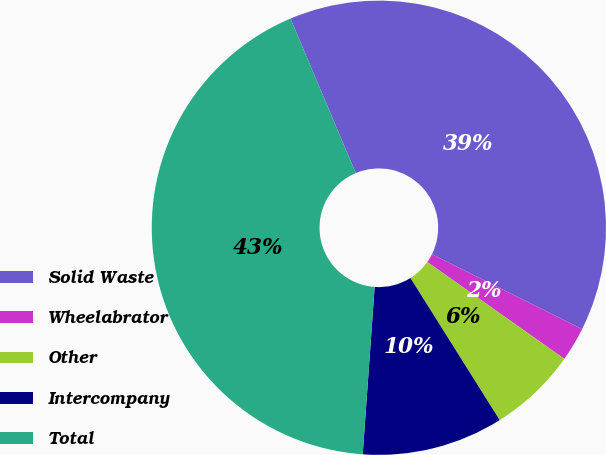Convert chart. <chart><loc_0><loc_0><loc_500><loc_500><pie_chart><fcel>Solid Waste<fcel>Wheelabrator<fcel>Other<fcel>Intercompany<fcel>Total<nl><fcel>38.73%<fcel>2.43%<fcel>6.28%<fcel>10.06%<fcel>42.51%<nl></chart> 